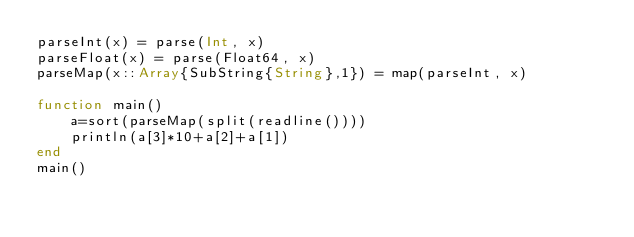<code> <loc_0><loc_0><loc_500><loc_500><_Julia_>parseInt(x) = parse(Int, x)
parseFloat(x) = parse(Float64, x)
parseMap(x::Array{SubString{String},1}) = map(parseInt, x)

function main()
    a=sort(parseMap(split(readline())))
    println(a[3]*10+a[2]+a[1])
end
main()</code> 